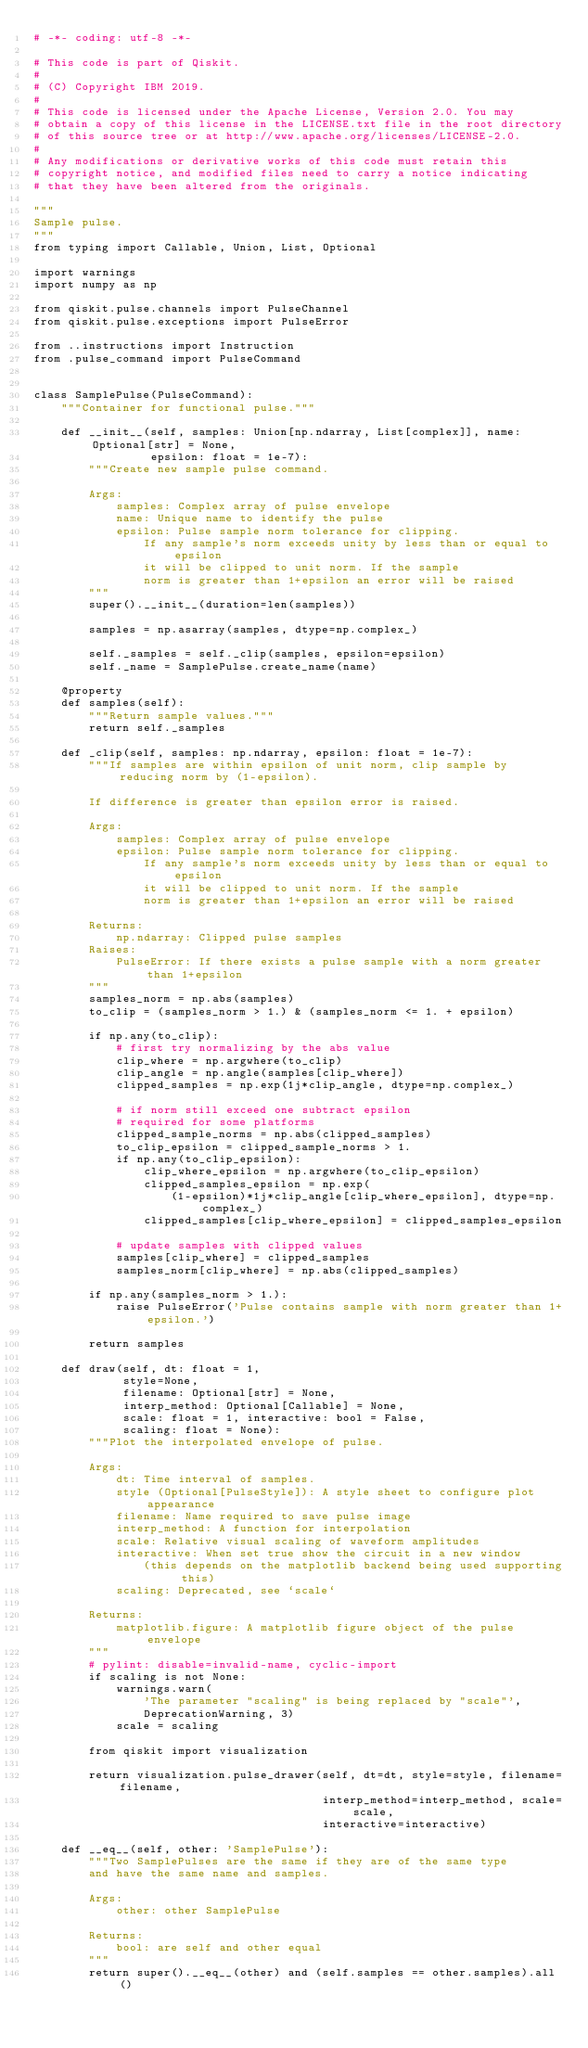<code> <loc_0><loc_0><loc_500><loc_500><_Python_># -*- coding: utf-8 -*-

# This code is part of Qiskit.
#
# (C) Copyright IBM 2019.
#
# This code is licensed under the Apache License, Version 2.0. You may
# obtain a copy of this license in the LICENSE.txt file in the root directory
# of this source tree or at http://www.apache.org/licenses/LICENSE-2.0.
#
# Any modifications or derivative works of this code must retain this
# copyright notice, and modified files need to carry a notice indicating
# that they have been altered from the originals.

"""
Sample pulse.
"""
from typing import Callable, Union, List, Optional

import warnings
import numpy as np

from qiskit.pulse.channels import PulseChannel
from qiskit.pulse.exceptions import PulseError

from ..instructions import Instruction
from .pulse_command import PulseCommand


class SamplePulse(PulseCommand):
    """Container for functional pulse."""

    def __init__(self, samples: Union[np.ndarray, List[complex]], name: Optional[str] = None,
                 epsilon: float = 1e-7):
        """Create new sample pulse command.

        Args:
            samples: Complex array of pulse envelope
            name: Unique name to identify the pulse
            epsilon: Pulse sample norm tolerance for clipping.
                If any sample's norm exceeds unity by less than or equal to epsilon
                it will be clipped to unit norm. If the sample
                norm is greater than 1+epsilon an error will be raised
        """
        super().__init__(duration=len(samples))

        samples = np.asarray(samples, dtype=np.complex_)

        self._samples = self._clip(samples, epsilon=epsilon)
        self._name = SamplePulse.create_name(name)

    @property
    def samples(self):
        """Return sample values."""
        return self._samples

    def _clip(self, samples: np.ndarray, epsilon: float = 1e-7):
        """If samples are within epsilon of unit norm, clip sample by reducing norm by (1-epsilon).

        If difference is greater than epsilon error is raised.

        Args:
            samples: Complex array of pulse envelope
            epsilon: Pulse sample norm tolerance for clipping.
                If any sample's norm exceeds unity by less than or equal to epsilon
                it will be clipped to unit norm. If the sample
                norm is greater than 1+epsilon an error will be raised

        Returns:
            np.ndarray: Clipped pulse samples
        Raises:
            PulseError: If there exists a pulse sample with a norm greater than 1+epsilon
        """
        samples_norm = np.abs(samples)
        to_clip = (samples_norm > 1.) & (samples_norm <= 1. + epsilon)

        if np.any(to_clip):
            # first try normalizing by the abs value
            clip_where = np.argwhere(to_clip)
            clip_angle = np.angle(samples[clip_where])
            clipped_samples = np.exp(1j*clip_angle, dtype=np.complex_)

            # if norm still exceed one subtract epsilon
            # required for some platforms
            clipped_sample_norms = np.abs(clipped_samples)
            to_clip_epsilon = clipped_sample_norms > 1.
            if np.any(to_clip_epsilon):
                clip_where_epsilon = np.argwhere(to_clip_epsilon)
                clipped_samples_epsilon = np.exp(
                    (1-epsilon)*1j*clip_angle[clip_where_epsilon], dtype=np.complex_)
                clipped_samples[clip_where_epsilon] = clipped_samples_epsilon

            # update samples with clipped values
            samples[clip_where] = clipped_samples
            samples_norm[clip_where] = np.abs(clipped_samples)

        if np.any(samples_norm > 1.):
            raise PulseError('Pulse contains sample with norm greater than 1+epsilon.')

        return samples

    def draw(self, dt: float = 1,
             style=None,
             filename: Optional[str] = None,
             interp_method: Optional[Callable] = None,
             scale: float = 1, interactive: bool = False,
             scaling: float = None):
        """Plot the interpolated envelope of pulse.

        Args:
            dt: Time interval of samples.
            style (Optional[PulseStyle]): A style sheet to configure plot appearance
            filename: Name required to save pulse image
            interp_method: A function for interpolation
            scale: Relative visual scaling of waveform amplitudes
            interactive: When set true show the circuit in a new window
                (this depends on the matplotlib backend being used supporting this)
            scaling: Deprecated, see `scale`

        Returns:
            matplotlib.figure: A matplotlib figure object of the pulse envelope
        """
        # pylint: disable=invalid-name, cyclic-import
        if scaling is not None:
            warnings.warn(
                'The parameter "scaling" is being replaced by "scale"',
                DeprecationWarning, 3)
            scale = scaling

        from qiskit import visualization

        return visualization.pulse_drawer(self, dt=dt, style=style, filename=filename,
                                          interp_method=interp_method, scale=scale,
                                          interactive=interactive)

    def __eq__(self, other: 'SamplePulse'):
        """Two SamplePulses are the same if they are of the same type
        and have the same name and samples.

        Args:
            other: other SamplePulse

        Returns:
            bool: are self and other equal
        """
        return super().__eq__(other) and (self.samples == other.samples).all()
</code> 